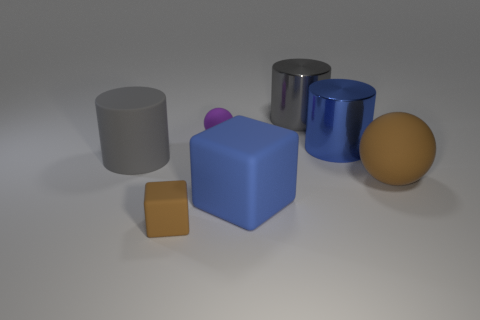There is a big gray thing behind the small purple ball; is it the same shape as the big object in front of the big brown matte sphere?
Provide a short and direct response. No. The big object that is both right of the big gray metal cylinder and to the left of the big brown thing is what color?
Your answer should be very brief. Blue. Is the size of the gray cylinder that is behind the big blue cylinder the same as the object in front of the big block?
Offer a very short reply. No. What number of big rubber objects have the same color as the tiny cube?
Your answer should be compact. 1. What number of tiny things are either purple objects or gray matte objects?
Your answer should be compact. 1. Is the gray object that is on the right side of the small purple ball made of the same material as the brown sphere?
Your answer should be very brief. No. What color is the tiny matte thing behind the blue rubber cube?
Your answer should be compact. Purple. Is there a purple rubber cylinder that has the same size as the blue cube?
Your answer should be compact. No. There is a purple sphere that is the same size as the brown cube; what material is it?
Provide a short and direct response. Rubber. Does the blue metal object have the same size as the brown thing that is behind the brown rubber cube?
Ensure brevity in your answer.  Yes. 